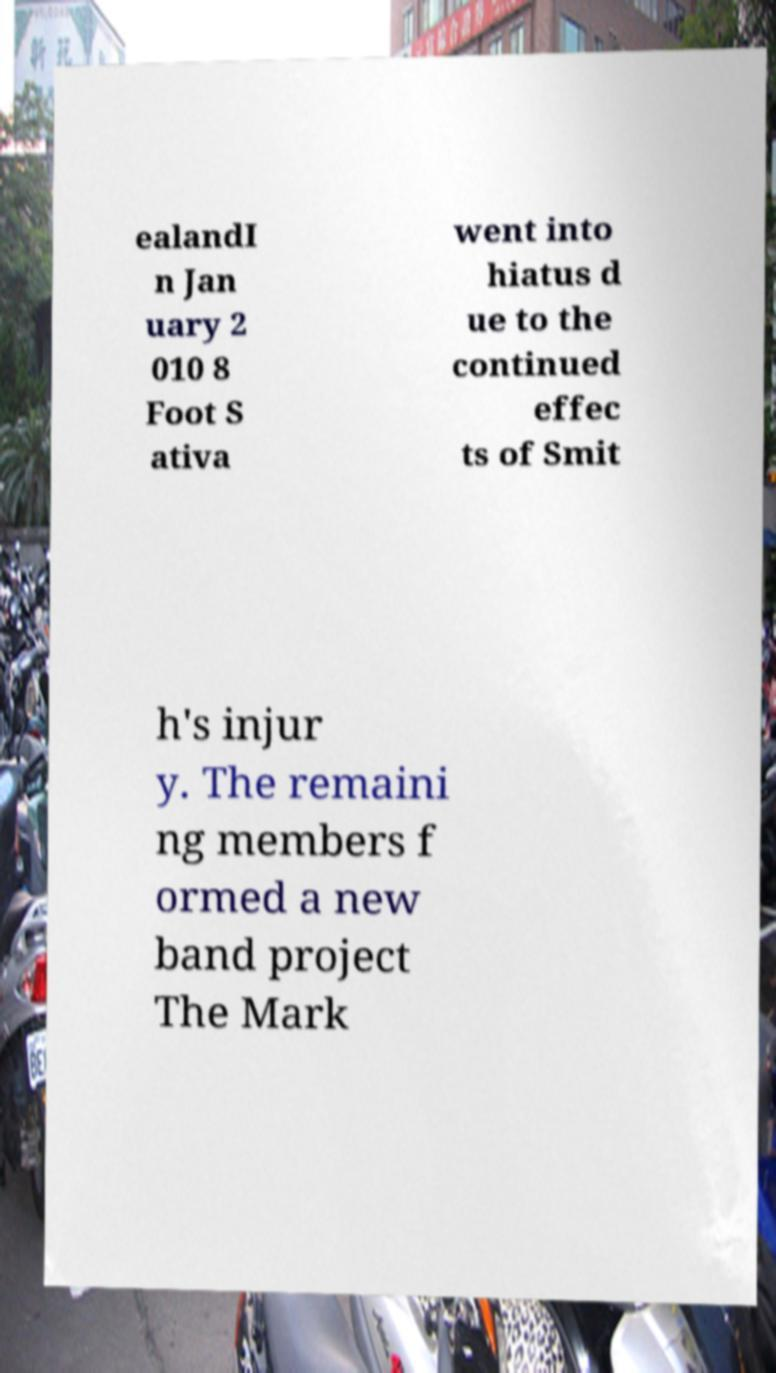I need the written content from this picture converted into text. Can you do that? ealandI n Jan uary 2 010 8 Foot S ativa went into hiatus d ue to the continued effec ts of Smit h's injur y. The remaini ng members f ormed a new band project The Mark 